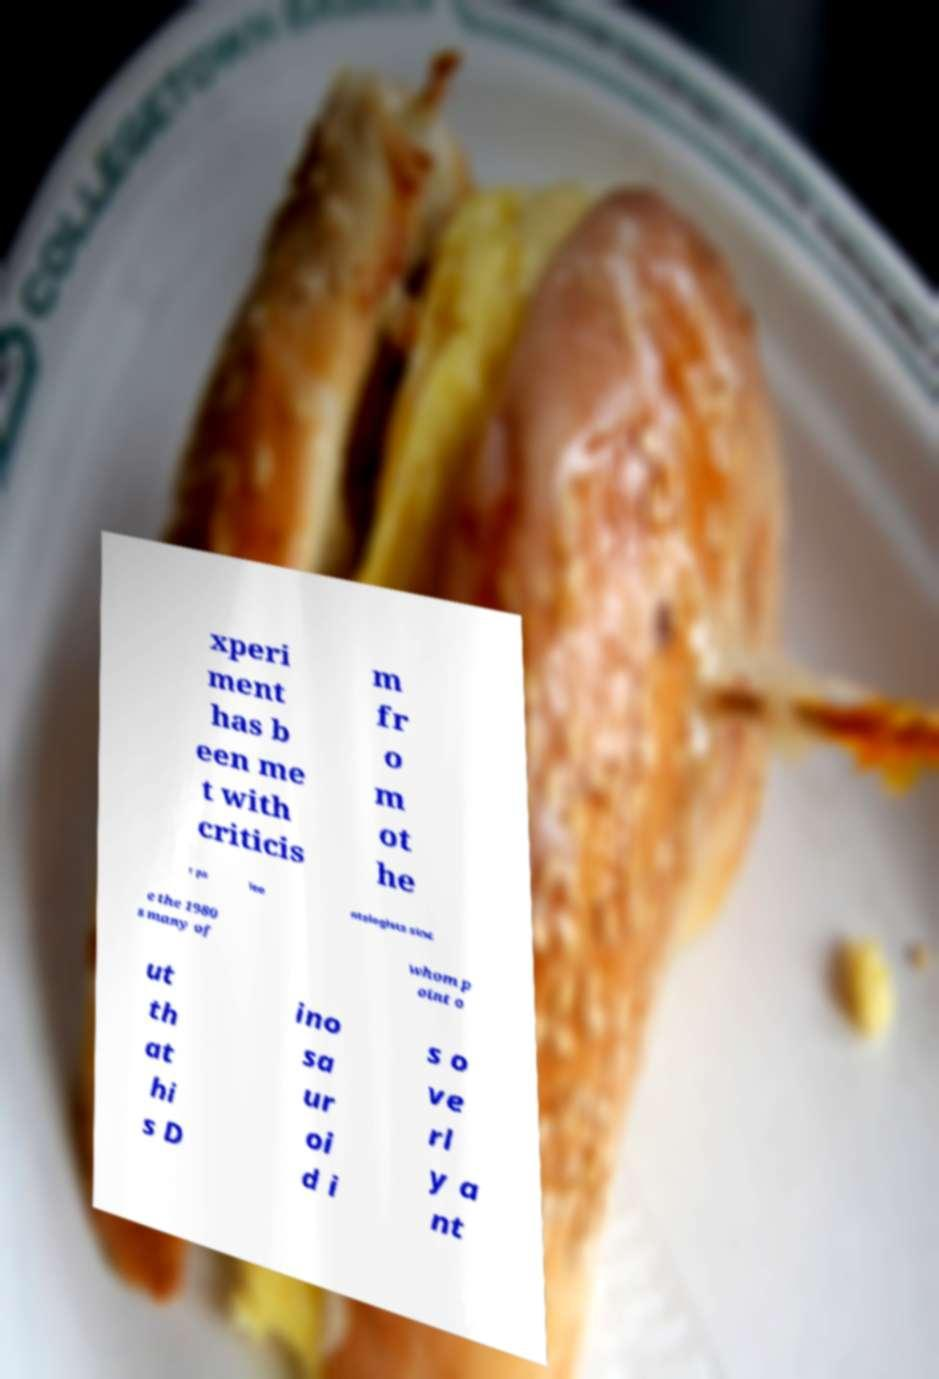For documentation purposes, I need the text within this image transcribed. Could you provide that? xperi ment has b een me t with criticis m fr o m ot he r pa leo ntologists sinc e the 1980 s many of whom p oint o ut th at hi s D ino sa ur oi d i s o ve rl y a nt 